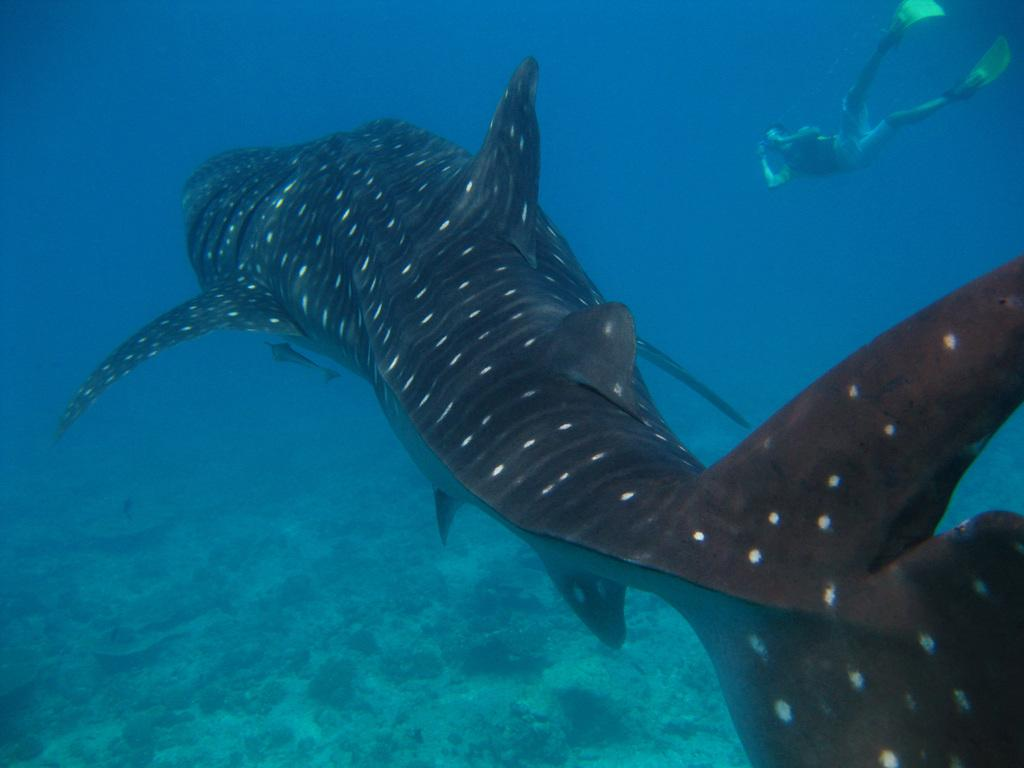What type of animal is in the image? There is a fish in the image. Who or what else is in the image? There is a person in the image. Where are the fish and person located in the image? Both the fish and the person are in the water. What type of popcorn is the person eating while swimming with the fish? There is no popcorn present in the image, and the person is not eating anything. 